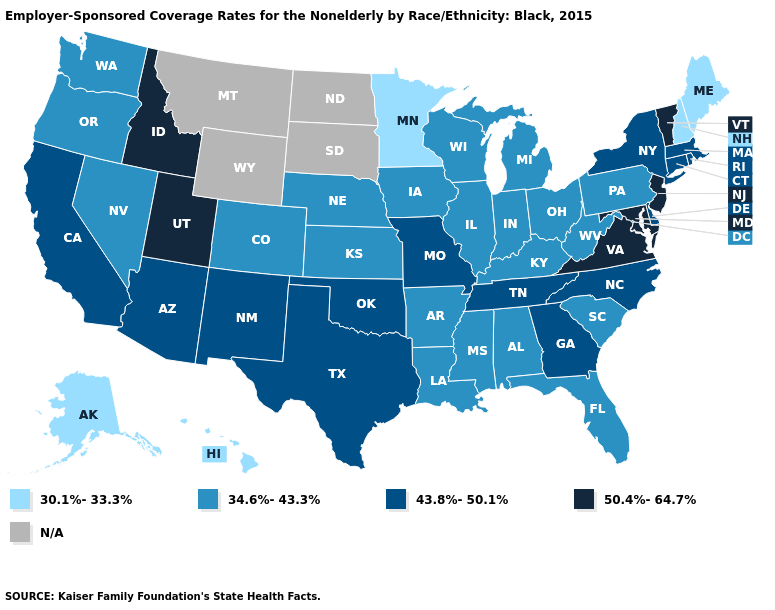Among the states that border West Virginia , does Virginia have the highest value?
Short answer required. Yes. What is the value of Michigan?
Answer briefly. 34.6%-43.3%. Which states hav the highest value in the South?
Answer briefly. Maryland, Virginia. Name the states that have a value in the range N/A?
Concise answer only. Montana, North Dakota, South Dakota, Wyoming. Does New Jersey have the highest value in the Northeast?
Write a very short answer. Yes. Name the states that have a value in the range N/A?
Quick response, please. Montana, North Dakota, South Dakota, Wyoming. Name the states that have a value in the range 50.4%-64.7%?
Short answer required. Idaho, Maryland, New Jersey, Utah, Vermont, Virginia. Does the map have missing data?
Short answer required. Yes. What is the lowest value in the Northeast?
Quick response, please. 30.1%-33.3%. Which states hav the highest value in the West?
Answer briefly. Idaho, Utah. Among the states that border Wyoming , which have the lowest value?
Give a very brief answer. Colorado, Nebraska. Name the states that have a value in the range 43.8%-50.1%?
Quick response, please. Arizona, California, Connecticut, Delaware, Georgia, Massachusetts, Missouri, New Mexico, New York, North Carolina, Oklahoma, Rhode Island, Tennessee, Texas. What is the value of Vermont?
Quick response, please. 50.4%-64.7%. Among the states that border Oregon , does Washington have the lowest value?
Write a very short answer. Yes. 